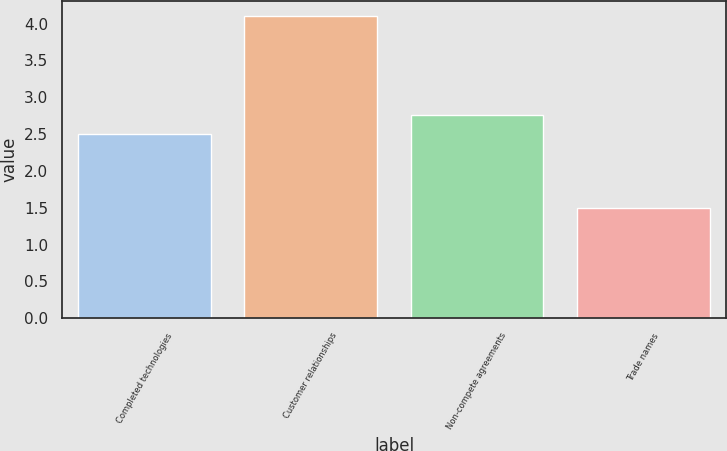<chart> <loc_0><loc_0><loc_500><loc_500><bar_chart><fcel>Completed technologies<fcel>Customer relationships<fcel>Non-compete agreements<fcel>Trade names<nl><fcel>2.5<fcel>4.1<fcel>2.76<fcel>1.5<nl></chart> 